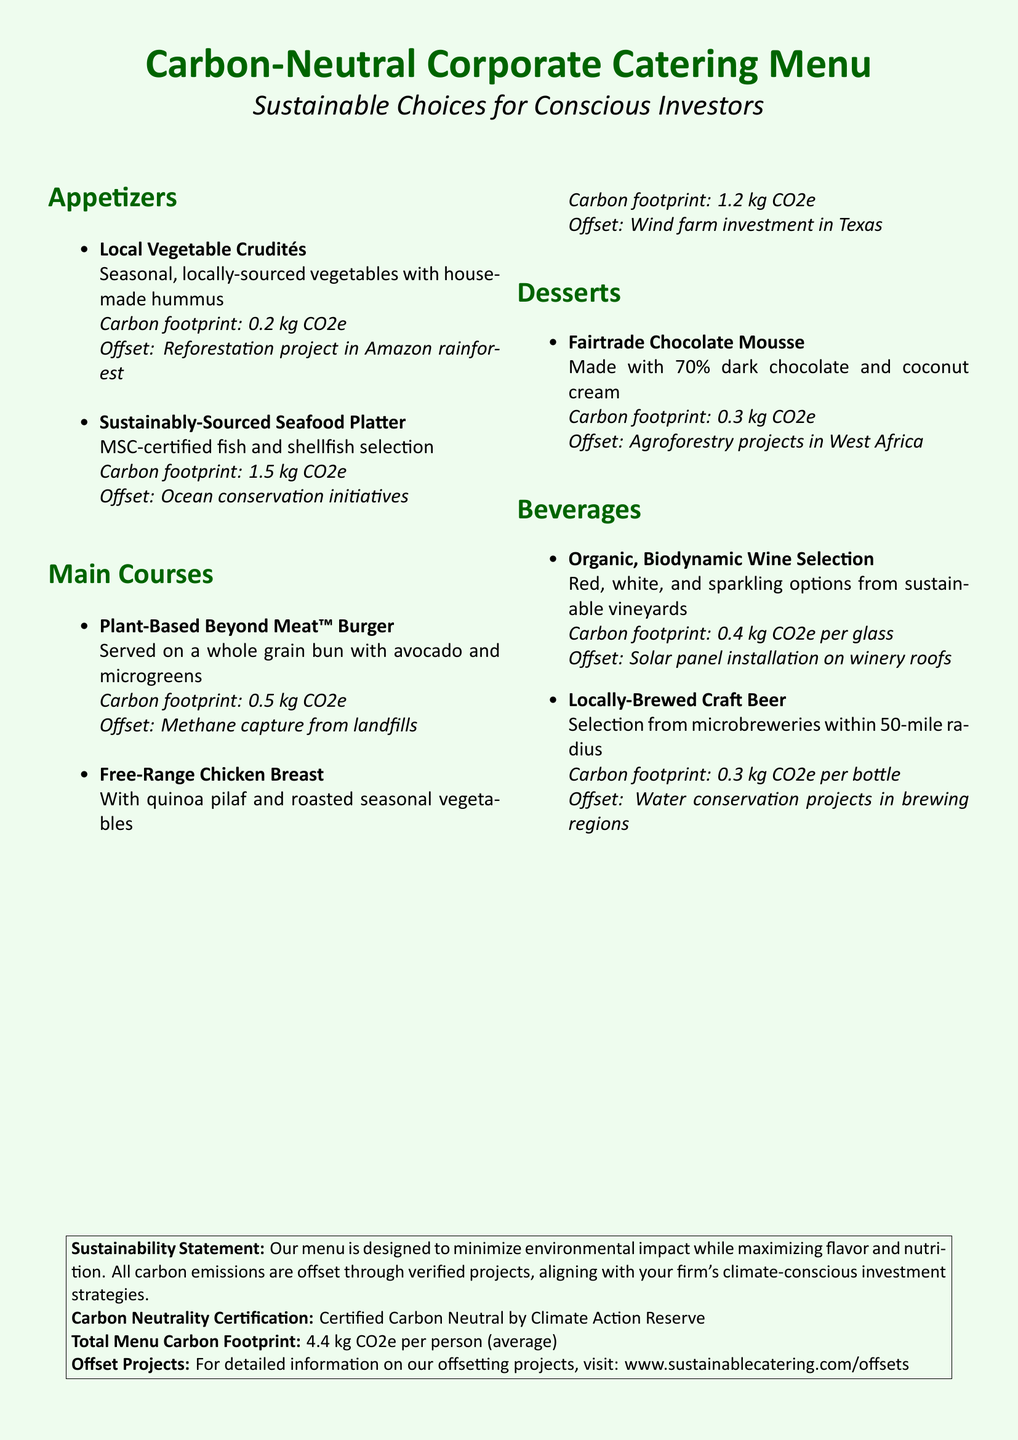What is the carbon footprint of the Local Vegetable Crudités? The carbon footprint is explicitly stated next to the dish, which is 0.2 kg CO2e.
Answer: 0.2 kg CO2e What offset project is associated with the Sustainably-Sourced Seafood Platter? The document mentions that the offset for this platter is related to ocean conservation initiatives.
Answer: Ocean conservation initiatives What is the carbon footprint of the Fairtrade Chocolate Mousse? The carbon footprint is stated in the menu, specifically noted as 0.3 kg CO2e.
Answer: 0.3 kg CO2e How many kg CO2e is the total menu carbon footprint per person? The total carbon footprint for the entire menu per person is specifically mentioned as 4.4 kg CO2e.
Answer: 4.4 kg CO2e What offset project is associated with the Free-Range Chicken Breast? The document specifies that this dish offsets through a wind farm investment in Texas.
Answer: Wind farm investment in Texas What type of certification does the catering menu have? The catering menu states that it is Certified Carbon Neutral by Climate Action Reserve.
Answer: Certified Carbon Neutral What is the carbon footprint per glass for the Organic, Biodynamic Wine Selection? The carbon footprint per glass for this selection is indicated as 0.4 kg CO2e.
Answer: 0.4 kg CO2e Which dish has the highest carbon footprint? By comparing the carbon footprints listed, the Sustainably-Sourced Seafood Platter has the highest footprint at 1.5 kg CO2e.
Answer: Sustainably-Sourced Seafood Platter 